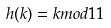<formula> <loc_0><loc_0><loc_500><loc_500>h ( k ) = k m o d 1 1</formula> 